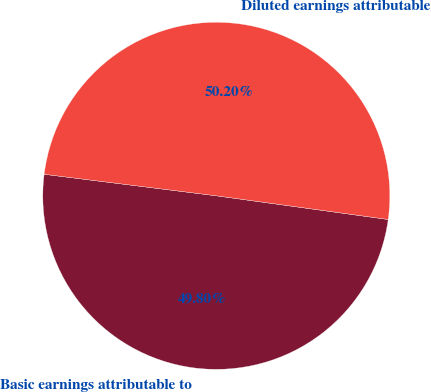<chart> <loc_0><loc_0><loc_500><loc_500><pie_chart><fcel>Basic earnings attributable to<fcel>Diluted earnings attributable<nl><fcel>49.8%<fcel>50.2%<nl></chart> 